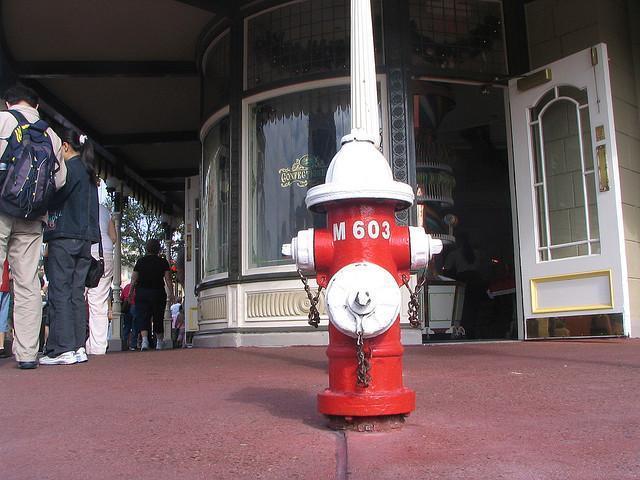How many fire hydrants can you see?
Give a very brief answer. 1. How many people can be seen?
Give a very brief answer. 4. How many pizza that has not been eaten?
Give a very brief answer. 0. 